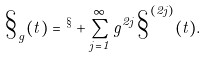Convert formula to latex. <formula><loc_0><loc_0><loc_500><loc_500>\S _ { g } ( t ) = \L ^ { \S } + \sum _ { j = 1 } ^ { \infty } g ^ { 2 j } \S ^ { ( 2 j ) } ( t ) .</formula> 